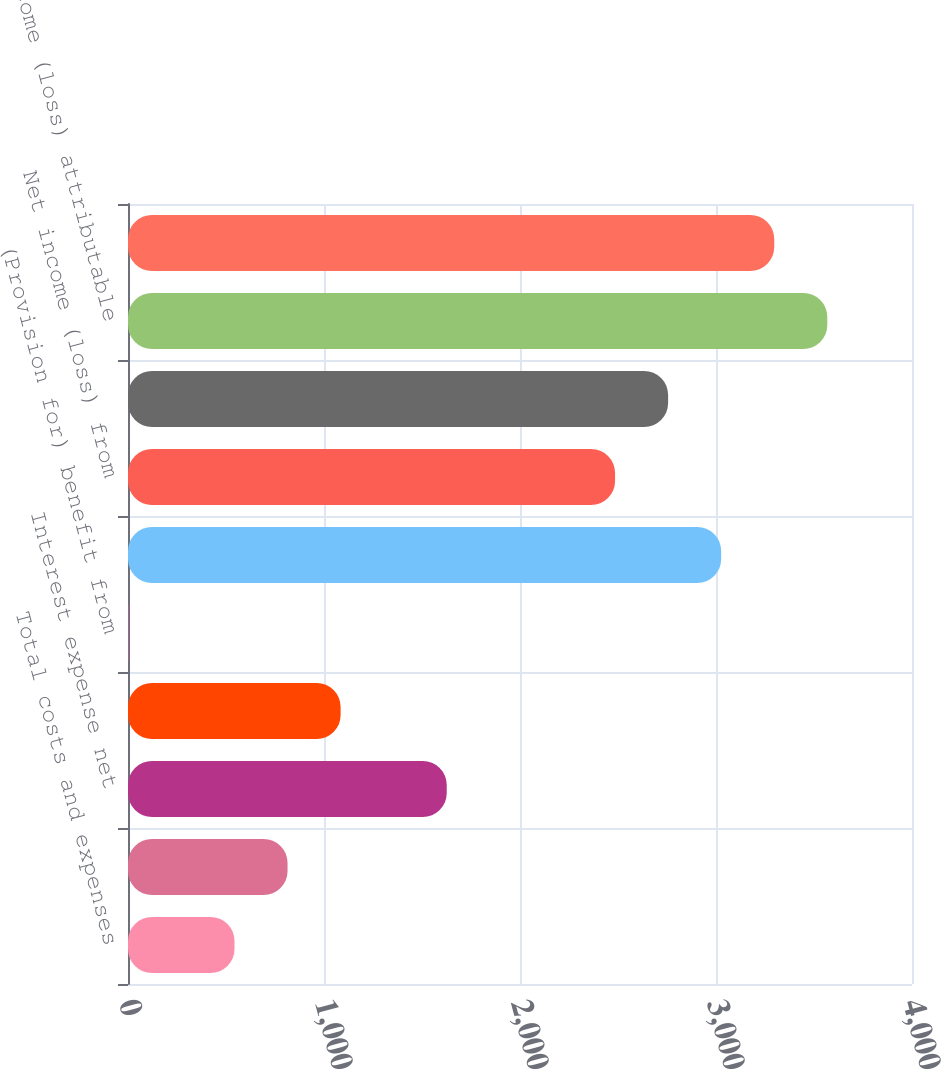Convert chart to OTSL. <chart><loc_0><loc_0><loc_500><loc_500><bar_chart><fcel>Total costs and expenses<fcel>Operating (loss) income<fcel>Interest expense net<fcel>Income (loss) before income<fcel>(Provision for) benefit from<fcel>Equity in affiliated<fcel>Net income (loss) from<fcel>Net income (loss)<fcel>Net income (loss) attributable<fcel>Total comprehensive income<nl><fcel>543.4<fcel>814.1<fcel>1626.2<fcel>1084.8<fcel>2<fcel>3026.4<fcel>2485<fcel>2755.7<fcel>3567.8<fcel>3297.1<nl></chart> 